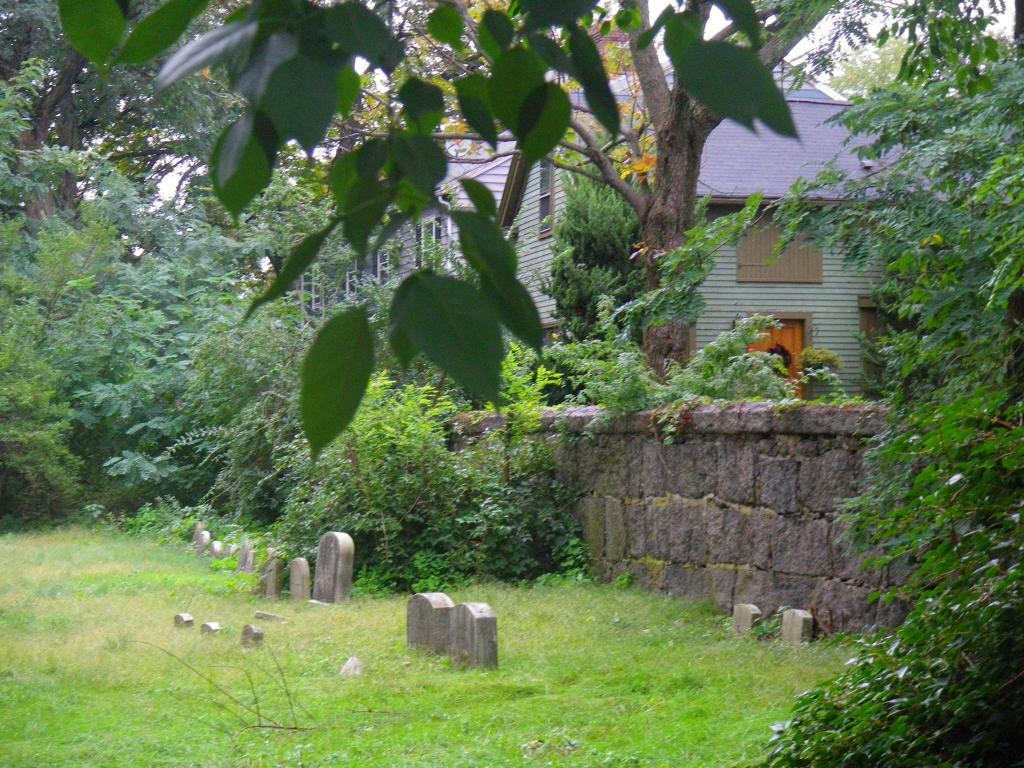In one or two sentences, can you explain what this image depicts? In the foreground of the picture we can see trees, grass and gravestones. In the middle of the picture there are trees, plants, wall, building and gravestones. In the background there are trees and sky. 